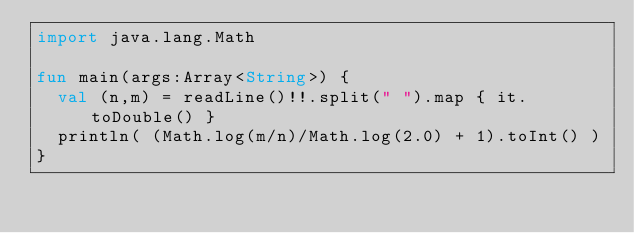Convert code to text. <code><loc_0><loc_0><loc_500><loc_500><_Kotlin_>import java.lang.Math

fun main(args:Array<String>) {
  val (n,m) = readLine()!!.split(" ").map { it.toDouble() }
  println( (Math.log(m/n)/Math.log(2.0) + 1).toInt() )
}</code> 